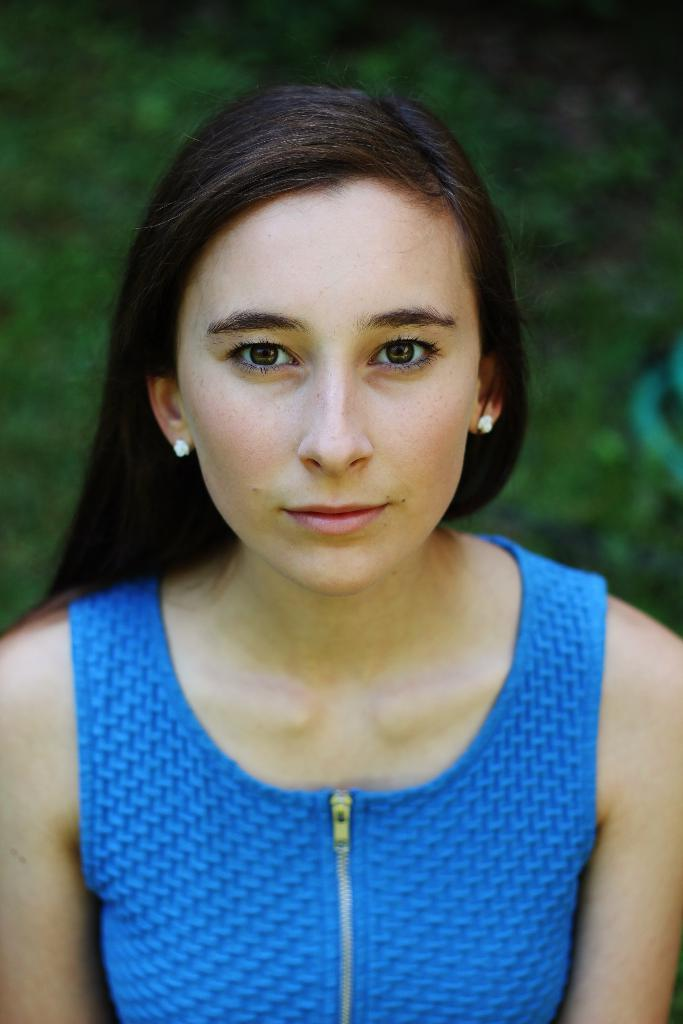Who is the main subject in the image? There is a woman in the image. What is the woman wearing? The woman is wearing a blue dress. Can you describe the background of the image? The background of the image is green and black. What type of ice can be seen melting on the wall in the image? There is no ice or wall present in the image; it features a woman wearing a blue dress with a green and black background. 